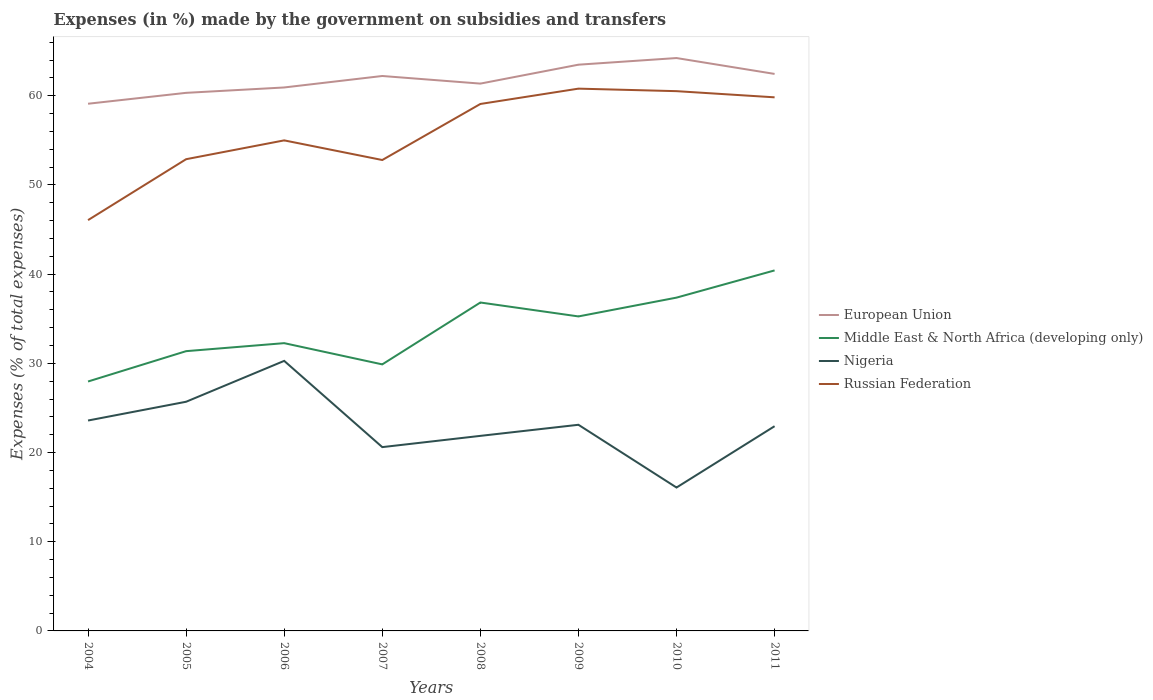Is the number of lines equal to the number of legend labels?
Provide a short and direct response. Yes. Across all years, what is the maximum percentage of expenses made by the government on subsidies and transfers in European Union?
Your answer should be very brief. 59.11. In which year was the percentage of expenses made by the government on subsidies and transfers in Nigeria maximum?
Provide a succinct answer. 2010. What is the total percentage of expenses made by the government on subsidies and transfers in European Union in the graph?
Offer a very short reply. -2.12. What is the difference between the highest and the second highest percentage of expenses made by the government on subsidies and transfers in Middle East & North Africa (developing only)?
Provide a short and direct response. 12.46. What is the difference between the highest and the lowest percentage of expenses made by the government on subsidies and transfers in Nigeria?
Ensure brevity in your answer.  4. How many lines are there?
Provide a short and direct response. 4. What is the difference between two consecutive major ticks on the Y-axis?
Offer a terse response. 10. Does the graph contain grids?
Your answer should be compact. No. Where does the legend appear in the graph?
Provide a short and direct response. Center right. How are the legend labels stacked?
Your answer should be compact. Vertical. What is the title of the graph?
Your answer should be very brief. Expenses (in %) made by the government on subsidies and transfers. What is the label or title of the Y-axis?
Offer a very short reply. Expenses (% of total expenses). What is the Expenses (% of total expenses) of European Union in 2004?
Your answer should be very brief. 59.11. What is the Expenses (% of total expenses) of Middle East & North Africa (developing only) in 2004?
Offer a terse response. 27.96. What is the Expenses (% of total expenses) of Nigeria in 2004?
Your answer should be compact. 23.59. What is the Expenses (% of total expenses) of Russian Federation in 2004?
Make the answer very short. 46.06. What is the Expenses (% of total expenses) of European Union in 2005?
Give a very brief answer. 60.33. What is the Expenses (% of total expenses) in Middle East & North Africa (developing only) in 2005?
Your response must be concise. 31.37. What is the Expenses (% of total expenses) in Nigeria in 2005?
Your response must be concise. 25.69. What is the Expenses (% of total expenses) in Russian Federation in 2005?
Your answer should be very brief. 52.89. What is the Expenses (% of total expenses) of European Union in 2006?
Provide a short and direct response. 60.93. What is the Expenses (% of total expenses) in Middle East & North Africa (developing only) in 2006?
Your answer should be very brief. 32.26. What is the Expenses (% of total expenses) of Nigeria in 2006?
Offer a very short reply. 30.28. What is the Expenses (% of total expenses) in Russian Federation in 2006?
Your response must be concise. 55. What is the Expenses (% of total expenses) of European Union in 2007?
Your answer should be compact. 62.22. What is the Expenses (% of total expenses) in Middle East & North Africa (developing only) in 2007?
Your answer should be compact. 29.88. What is the Expenses (% of total expenses) of Nigeria in 2007?
Provide a succinct answer. 20.61. What is the Expenses (% of total expenses) of Russian Federation in 2007?
Your response must be concise. 52.8. What is the Expenses (% of total expenses) in European Union in 2008?
Provide a short and direct response. 61.36. What is the Expenses (% of total expenses) in Middle East & North Africa (developing only) in 2008?
Offer a very short reply. 36.82. What is the Expenses (% of total expenses) of Nigeria in 2008?
Ensure brevity in your answer.  21.87. What is the Expenses (% of total expenses) in Russian Federation in 2008?
Your response must be concise. 59.08. What is the Expenses (% of total expenses) of European Union in 2009?
Your answer should be compact. 63.49. What is the Expenses (% of total expenses) in Middle East & North Africa (developing only) in 2009?
Keep it short and to the point. 35.26. What is the Expenses (% of total expenses) in Nigeria in 2009?
Provide a short and direct response. 23.11. What is the Expenses (% of total expenses) of Russian Federation in 2009?
Your answer should be compact. 60.8. What is the Expenses (% of total expenses) of European Union in 2010?
Your answer should be very brief. 64.23. What is the Expenses (% of total expenses) in Middle East & North Africa (developing only) in 2010?
Ensure brevity in your answer.  37.37. What is the Expenses (% of total expenses) of Nigeria in 2010?
Make the answer very short. 16.08. What is the Expenses (% of total expenses) of Russian Federation in 2010?
Provide a succinct answer. 60.52. What is the Expenses (% of total expenses) of European Union in 2011?
Make the answer very short. 62.45. What is the Expenses (% of total expenses) of Middle East & North Africa (developing only) in 2011?
Provide a short and direct response. 40.42. What is the Expenses (% of total expenses) in Nigeria in 2011?
Your answer should be very brief. 22.95. What is the Expenses (% of total expenses) of Russian Federation in 2011?
Offer a very short reply. 59.83. Across all years, what is the maximum Expenses (% of total expenses) in European Union?
Keep it short and to the point. 64.23. Across all years, what is the maximum Expenses (% of total expenses) of Middle East & North Africa (developing only)?
Keep it short and to the point. 40.42. Across all years, what is the maximum Expenses (% of total expenses) in Nigeria?
Keep it short and to the point. 30.28. Across all years, what is the maximum Expenses (% of total expenses) in Russian Federation?
Provide a succinct answer. 60.8. Across all years, what is the minimum Expenses (% of total expenses) of European Union?
Ensure brevity in your answer.  59.11. Across all years, what is the minimum Expenses (% of total expenses) of Middle East & North Africa (developing only)?
Your answer should be compact. 27.96. Across all years, what is the minimum Expenses (% of total expenses) of Nigeria?
Give a very brief answer. 16.08. Across all years, what is the minimum Expenses (% of total expenses) of Russian Federation?
Your answer should be very brief. 46.06. What is the total Expenses (% of total expenses) of European Union in the graph?
Offer a terse response. 494.11. What is the total Expenses (% of total expenses) of Middle East & North Africa (developing only) in the graph?
Your answer should be very brief. 271.35. What is the total Expenses (% of total expenses) in Nigeria in the graph?
Provide a succinct answer. 184.18. What is the total Expenses (% of total expenses) of Russian Federation in the graph?
Provide a succinct answer. 446.97. What is the difference between the Expenses (% of total expenses) in European Union in 2004 and that in 2005?
Offer a very short reply. -1.22. What is the difference between the Expenses (% of total expenses) in Middle East & North Africa (developing only) in 2004 and that in 2005?
Make the answer very short. -3.4. What is the difference between the Expenses (% of total expenses) in Nigeria in 2004 and that in 2005?
Your answer should be very brief. -2.1. What is the difference between the Expenses (% of total expenses) of Russian Federation in 2004 and that in 2005?
Give a very brief answer. -6.83. What is the difference between the Expenses (% of total expenses) of European Union in 2004 and that in 2006?
Offer a very short reply. -1.83. What is the difference between the Expenses (% of total expenses) in Middle East & North Africa (developing only) in 2004 and that in 2006?
Offer a very short reply. -4.3. What is the difference between the Expenses (% of total expenses) of Nigeria in 2004 and that in 2006?
Provide a succinct answer. -6.69. What is the difference between the Expenses (% of total expenses) of Russian Federation in 2004 and that in 2006?
Give a very brief answer. -8.94. What is the difference between the Expenses (% of total expenses) in European Union in 2004 and that in 2007?
Offer a terse response. -3.11. What is the difference between the Expenses (% of total expenses) of Middle East & North Africa (developing only) in 2004 and that in 2007?
Offer a very short reply. -1.92. What is the difference between the Expenses (% of total expenses) of Nigeria in 2004 and that in 2007?
Your response must be concise. 2.98. What is the difference between the Expenses (% of total expenses) in Russian Federation in 2004 and that in 2007?
Provide a short and direct response. -6.74. What is the difference between the Expenses (% of total expenses) of European Union in 2004 and that in 2008?
Offer a very short reply. -2.26. What is the difference between the Expenses (% of total expenses) in Middle East & North Africa (developing only) in 2004 and that in 2008?
Give a very brief answer. -8.86. What is the difference between the Expenses (% of total expenses) of Nigeria in 2004 and that in 2008?
Provide a short and direct response. 1.72. What is the difference between the Expenses (% of total expenses) in Russian Federation in 2004 and that in 2008?
Make the answer very short. -13.02. What is the difference between the Expenses (% of total expenses) of European Union in 2004 and that in 2009?
Offer a terse response. -4.38. What is the difference between the Expenses (% of total expenses) of Middle East & North Africa (developing only) in 2004 and that in 2009?
Ensure brevity in your answer.  -7.3. What is the difference between the Expenses (% of total expenses) in Nigeria in 2004 and that in 2009?
Offer a very short reply. 0.48. What is the difference between the Expenses (% of total expenses) in Russian Federation in 2004 and that in 2009?
Your response must be concise. -14.74. What is the difference between the Expenses (% of total expenses) in European Union in 2004 and that in 2010?
Ensure brevity in your answer.  -5.12. What is the difference between the Expenses (% of total expenses) of Middle East & North Africa (developing only) in 2004 and that in 2010?
Offer a terse response. -9.4. What is the difference between the Expenses (% of total expenses) of Nigeria in 2004 and that in 2010?
Offer a terse response. 7.51. What is the difference between the Expenses (% of total expenses) of Russian Federation in 2004 and that in 2010?
Offer a terse response. -14.46. What is the difference between the Expenses (% of total expenses) of European Union in 2004 and that in 2011?
Your answer should be very brief. -3.34. What is the difference between the Expenses (% of total expenses) in Middle East & North Africa (developing only) in 2004 and that in 2011?
Give a very brief answer. -12.46. What is the difference between the Expenses (% of total expenses) in Nigeria in 2004 and that in 2011?
Provide a succinct answer. 0.64. What is the difference between the Expenses (% of total expenses) in Russian Federation in 2004 and that in 2011?
Ensure brevity in your answer.  -13.77. What is the difference between the Expenses (% of total expenses) of European Union in 2005 and that in 2006?
Give a very brief answer. -0.6. What is the difference between the Expenses (% of total expenses) of Middle East & North Africa (developing only) in 2005 and that in 2006?
Provide a short and direct response. -0.9. What is the difference between the Expenses (% of total expenses) of Nigeria in 2005 and that in 2006?
Provide a short and direct response. -4.58. What is the difference between the Expenses (% of total expenses) in Russian Federation in 2005 and that in 2006?
Keep it short and to the point. -2.11. What is the difference between the Expenses (% of total expenses) of European Union in 2005 and that in 2007?
Your answer should be compact. -1.89. What is the difference between the Expenses (% of total expenses) in Middle East & North Africa (developing only) in 2005 and that in 2007?
Your answer should be compact. 1.48. What is the difference between the Expenses (% of total expenses) in Nigeria in 2005 and that in 2007?
Give a very brief answer. 5.09. What is the difference between the Expenses (% of total expenses) of Russian Federation in 2005 and that in 2007?
Provide a short and direct response. 0.09. What is the difference between the Expenses (% of total expenses) in European Union in 2005 and that in 2008?
Offer a very short reply. -1.04. What is the difference between the Expenses (% of total expenses) in Middle East & North Africa (developing only) in 2005 and that in 2008?
Give a very brief answer. -5.45. What is the difference between the Expenses (% of total expenses) in Nigeria in 2005 and that in 2008?
Give a very brief answer. 3.83. What is the difference between the Expenses (% of total expenses) in Russian Federation in 2005 and that in 2008?
Give a very brief answer. -6.19. What is the difference between the Expenses (% of total expenses) in European Union in 2005 and that in 2009?
Provide a short and direct response. -3.16. What is the difference between the Expenses (% of total expenses) of Middle East & North Africa (developing only) in 2005 and that in 2009?
Give a very brief answer. -3.89. What is the difference between the Expenses (% of total expenses) of Nigeria in 2005 and that in 2009?
Ensure brevity in your answer.  2.58. What is the difference between the Expenses (% of total expenses) of Russian Federation in 2005 and that in 2009?
Your answer should be very brief. -7.91. What is the difference between the Expenses (% of total expenses) in European Union in 2005 and that in 2010?
Provide a short and direct response. -3.9. What is the difference between the Expenses (% of total expenses) in Middle East & North Africa (developing only) in 2005 and that in 2010?
Provide a short and direct response. -6. What is the difference between the Expenses (% of total expenses) of Nigeria in 2005 and that in 2010?
Offer a terse response. 9.62. What is the difference between the Expenses (% of total expenses) of Russian Federation in 2005 and that in 2010?
Your answer should be compact. -7.63. What is the difference between the Expenses (% of total expenses) of European Union in 2005 and that in 2011?
Provide a short and direct response. -2.12. What is the difference between the Expenses (% of total expenses) of Middle East & North Africa (developing only) in 2005 and that in 2011?
Make the answer very short. -9.05. What is the difference between the Expenses (% of total expenses) of Nigeria in 2005 and that in 2011?
Give a very brief answer. 2.74. What is the difference between the Expenses (% of total expenses) of Russian Federation in 2005 and that in 2011?
Give a very brief answer. -6.94. What is the difference between the Expenses (% of total expenses) of European Union in 2006 and that in 2007?
Your response must be concise. -1.29. What is the difference between the Expenses (% of total expenses) of Middle East & North Africa (developing only) in 2006 and that in 2007?
Provide a succinct answer. 2.38. What is the difference between the Expenses (% of total expenses) of Nigeria in 2006 and that in 2007?
Your answer should be very brief. 9.67. What is the difference between the Expenses (% of total expenses) of Russian Federation in 2006 and that in 2007?
Offer a terse response. 2.2. What is the difference between the Expenses (% of total expenses) in European Union in 2006 and that in 2008?
Your answer should be compact. -0.43. What is the difference between the Expenses (% of total expenses) in Middle East & North Africa (developing only) in 2006 and that in 2008?
Give a very brief answer. -4.56. What is the difference between the Expenses (% of total expenses) in Nigeria in 2006 and that in 2008?
Offer a very short reply. 8.41. What is the difference between the Expenses (% of total expenses) in Russian Federation in 2006 and that in 2008?
Give a very brief answer. -4.08. What is the difference between the Expenses (% of total expenses) in European Union in 2006 and that in 2009?
Ensure brevity in your answer.  -2.55. What is the difference between the Expenses (% of total expenses) of Middle East & North Africa (developing only) in 2006 and that in 2009?
Make the answer very short. -3. What is the difference between the Expenses (% of total expenses) of Nigeria in 2006 and that in 2009?
Provide a succinct answer. 7.17. What is the difference between the Expenses (% of total expenses) in Russian Federation in 2006 and that in 2009?
Provide a succinct answer. -5.8. What is the difference between the Expenses (% of total expenses) in European Union in 2006 and that in 2010?
Your answer should be compact. -3.3. What is the difference between the Expenses (% of total expenses) in Middle East & North Africa (developing only) in 2006 and that in 2010?
Keep it short and to the point. -5.1. What is the difference between the Expenses (% of total expenses) of Nigeria in 2006 and that in 2010?
Your answer should be very brief. 14.2. What is the difference between the Expenses (% of total expenses) in Russian Federation in 2006 and that in 2010?
Your answer should be very brief. -5.52. What is the difference between the Expenses (% of total expenses) in European Union in 2006 and that in 2011?
Keep it short and to the point. -1.52. What is the difference between the Expenses (% of total expenses) in Middle East & North Africa (developing only) in 2006 and that in 2011?
Your response must be concise. -8.16. What is the difference between the Expenses (% of total expenses) of Nigeria in 2006 and that in 2011?
Ensure brevity in your answer.  7.32. What is the difference between the Expenses (% of total expenses) of Russian Federation in 2006 and that in 2011?
Give a very brief answer. -4.83. What is the difference between the Expenses (% of total expenses) of European Union in 2007 and that in 2008?
Keep it short and to the point. 0.85. What is the difference between the Expenses (% of total expenses) in Middle East & North Africa (developing only) in 2007 and that in 2008?
Offer a terse response. -6.94. What is the difference between the Expenses (% of total expenses) of Nigeria in 2007 and that in 2008?
Keep it short and to the point. -1.26. What is the difference between the Expenses (% of total expenses) of Russian Federation in 2007 and that in 2008?
Provide a short and direct response. -6.28. What is the difference between the Expenses (% of total expenses) in European Union in 2007 and that in 2009?
Ensure brevity in your answer.  -1.27. What is the difference between the Expenses (% of total expenses) of Middle East & North Africa (developing only) in 2007 and that in 2009?
Make the answer very short. -5.38. What is the difference between the Expenses (% of total expenses) of Nigeria in 2007 and that in 2009?
Offer a very short reply. -2.5. What is the difference between the Expenses (% of total expenses) in Russian Federation in 2007 and that in 2009?
Your answer should be very brief. -8. What is the difference between the Expenses (% of total expenses) of European Union in 2007 and that in 2010?
Keep it short and to the point. -2.01. What is the difference between the Expenses (% of total expenses) of Middle East & North Africa (developing only) in 2007 and that in 2010?
Provide a succinct answer. -7.48. What is the difference between the Expenses (% of total expenses) in Nigeria in 2007 and that in 2010?
Give a very brief answer. 4.53. What is the difference between the Expenses (% of total expenses) of Russian Federation in 2007 and that in 2010?
Give a very brief answer. -7.72. What is the difference between the Expenses (% of total expenses) in European Union in 2007 and that in 2011?
Make the answer very short. -0.23. What is the difference between the Expenses (% of total expenses) in Middle East & North Africa (developing only) in 2007 and that in 2011?
Provide a succinct answer. -10.54. What is the difference between the Expenses (% of total expenses) in Nigeria in 2007 and that in 2011?
Offer a very short reply. -2.35. What is the difference between the Expenses (% of total expenses) of Russian Federation in 2007 and that in 2011?
Keep it short and to the point. -7.03. What is the difference between the Expenses (% of total expenses) in European Union in 2008 and that in 2009?
Your answer should be compact. -2.12. What is the difference between the Expenses (% of total expenses) of Middle East & North Africa (developing only) in 2008 and that in 2009?
Make the answer very short. 1.56. What is the difference between the Expenses (% of total expenses) of Nigeria in 2008 and that in 2009?
Provide a succinct answer. -1.24. What is the difference between the Expenses (% of total expenses) in Russian Federation in 2008 and that in 2009?
Provide a succinct answer. -1.72. What is the difference between the Expenses (% of total expenses) in European Union in 2008 and that in 2010?
Keep it short and to the point. -2.87. What is the difference between the Expenses (% of total expenses) of Middle East & North Africa (developing only) in 2008 and that in 2010?
Make the answer very short. -0.55. What is the difference between the Expenses (% of total expenses) in Nigeria in 2008 and that in 2010?
Provide a succinct answer. 5.79. What is the difference between the Expenses (% of total expenses) of Russian Federation in 2008 and that in 2010?
Make the answer very short. -1.44. What is the difference between the Expenses (% of total expenses) in European Union in 2008 and that in 2011?
Your response must be concise. -1.09. What is the difference between the Expenses (% of total expenses) of Middle East & North Africa (developing only) in 2008 and that in 2011?
Your answer should be compact. -3.6. What is the difference between the Expenses (% of total expenses) in Nigeria in 2008 and that in 2011?
Offer a terse response. -1.09. What is the difference between the Expenses (% of total expenses) of Russian Federation in 2008 and that in 2011?
Your answer should be compact. -0.74. What is the difference between the Expenses (% of total expenses) in European Union in 2009 and that in 2010?
Provide a short and direct response. -0.74. What is the difference between the Expenses (% of total expenses) of Middle East & North Africa (developing only) in 2009 and that in 2010?
Keep it short and to the point. -2.11. What is the difference between the Expenses (% of total expenses) of Nigeria in 2009 and that in 2010?
Give a very brief answer. 7.03. What is the difference between the Expenses (% of total expenses) in Russian Federation in 2009 and that in 2010?
Your response must be concise. 0.28. What is the difference between the Expenses (% of total expenses) in European Union in 2009 and that in 2011?
Ensure brevity in your answer.  1.04. What is the difference between the Expenses (% of total expenses) of Middle East & North Africa (developing only) in 2009 and that in 2011?
Offer a very short reply. -5.16. What is the difference between the Expenses (% of total expenses) in Nigeria in 2009 and that in 2011?
Offer a terse response. 0.16. What is the difference between the Expenses (% of total expenses) of Russian Federation in 2009 and that in 2011?
Make the answer very short. 0.97. What is the difference between the Expenses (% of total expenses) of European Union in 2010 and that in 2011?
Offer a very short reply. 1.78. What is the difference between the Expenses (% of total expenses) in Middle East & North Africa (developing only) in 2010 and that in 2011?
Give a very brief answer. -3.05. What is the difference between the Expenses (% of total expenses) in Nigeria in 2010 and that in 2011?
Ensure brevity in your answer.  -6.88. What is the difference between the Expenses (% of total expenses) in Russian Federation in 2010 and that in 2011?
Offer a very short reply. 0.69. What is the difference between the Expenses (% of total expenses) of European Union in 2004 and the Expenses (% of total expenses) of Middle East & North Africa (developing only) in 2005?
Provide a succinct answer. 27.74. What is the difference between the Expenses (% of total expenses) of European Union in 2004 and the Expenses (% of total expenses) of Nigeria in 2005?
Ensure brevity in your answer.  33.41. What is the difference between the Expenses (% of total expenses) in European Union in 2004 and the Expenses (% of total expenses) in Russian Federation in 2005?
Make the answer very short. 6.22. What is the difference between the Expenses (% of total expenses) of Middle East & North Africa (developing only) in 2004 and the Expenses (% of total expenses) of Nigeria in 2005?
Provide a short and direct response. 2.27. What is the difference between the Expenses (% of total expenses) of Middle East & North Africa (developing only) in 2004 and the Expenses (% of total expenses) of Russian Federation in 2005?
Your answer should be compact. -24.93. What is the difference between the Expenses (% of total expenses) in Nigeria in 2004 and the Expenses (% of total expenses) in Russian Federation in 2005?
Offer a terse response. -29.3. What is the difference between the Expenses (% of total expenses) in European Union in 2004 and the Expenses (% of total expenses) in Middle East & North Africa (developing only) in 2006?
Offer a terse response. 26.84. What is the difference between the Expenses (% of total expenses) in European Union in 2004 and the Expenses (% of total expenses) in Nigeria in 2006?
Offer a terse response. 28.83. What is the difference between the Expenses (% of total expenses) in European Union in 2004 and the Expenses (% of total expenses) in Russian Federation in 2006?
Your answer should be very brief. 4.11. What is the difference between the Expenses (% of total expenses) in Middle East & North Africa (developing only) in 2004 and the Expenses (% of total expenses) in Nigeria in 2006?
Offer a terse response. -2.31. What is the difference between the Expenses (% of total expenses) in Middle East & North Africa (developing only) in 2004 and the Expenses (% of total expenses) in Russian Federation in 2006?
Your answer should be very brief. -27.04. What is the difference between the Expenses (% of total expenses) of Nigeria in 2004 and the Expenses (% of total expenses) of Russian Federation in 2006?
Provide a short and direct response. -31.41. What is the difference between the Expenses (% of total expenses) in European Union in 2004 and the Expenses (% of total expenses) in Middle East & North Africa (developing only) in 2007?
Offer a very short reply. 29.22. What is the difference between the Expenses (% of total expenses) in European Union in 2004 and the Expenses (% of total expenses) in Nigeria in 2007?
Provide a succinct answer. 38.5. What is the difference between the Expenses (% of total expenses) in European Union in 2004 and the Expenses (% of total expenses) in Russian Federation in 2007?
Your answer should be very brief. 6.31. What is the difference between the Expenses (% of total expenses) in Middle East & North Africa (developing only) in 2004 and the Expenses (% of total expenses) in Nigeria in 2007?
Ensure brevity in your answer.  7.36. What is the difference between the Expenses (% of total expenses) in Middle East & North Africa (developing only) in 2004 and the Expenses (% of total expenses) in Russian Federation in 2007?
Your response must be concise. -24.83. What is the difference between the Expenses (% of total expenses) in Nigeria in 2004 and the Expenses (% of total expenses) in Russian Federation in 2007?
Make the answer very short. -29.21. What is the difference between the Expenses (% of total expenses) of European Union in 2004 and the Expenses (% of total expenses) of Middle East & North Africa (developing only) in 2008?
Provide a succinct answer. 22.29. What is the difference between the Expenses (% of total expenses) of European Union in 2004 and the Expenses (% of total expenses) of Nigeria in 2008?
Make the answer very short. 37.24. What is the difference between the Expenses (% of total expenses) of European Union in 2004 and the Expenses (% of total expenses) of Russian Federation in 2008?
Offer a terse response. 0.03. What is the difference between the Expenses (% of total expenses) in Middle East & North Africa (developing only) in 2004 and the Expenses (% of total expenses) in Nigeria in 2008?
Give a very brief answer. 6.1. What is the difference between the Expenses (% of total expenses) of Middle East & North Africa (developing only) in 2004 and the Expenses (% of total expenses) of Russian Federation in 2008?
Provide a succinct answer. -31.12. What is the difference between the Expenses (% of total expenses) of Nigeria in 2004 and the Expenses (% of total expenses) of Russian Federation in 2008?
Make the answer very short. -35.49. What is the difference between the Expenses (% of total expenses) in European Union in 2004 and the Expenses (% of total expenses) in Middle East & North Africa (developing only) in 2009?
Your answer should be very brief. 23.85. What is the difference between the Expenses (% of total expenses) in European Union in 2004 and the Expenses (% of total expenses) in Nigeria in 2009?
Keep it short and to the point. 35.99. What is the difference between the Expenses (% of total expenses) in European Union in 2004 and the Expenses (% of total expenses) in Russian Federation in 2009?
Your response must be concise. -1.69. What is the difference between the Expenses (% of total expenses) of Middle East & North Africa (developing only) in 2004 and the Expenses (% of total expenses) of Nigeria in 2009?
Ensure brevity in your answer.  4.85. What is the difference between the Expenses (% of total expenses) in Middle East & North Africa (developing only) in 2004 and the Expenses (% of total expenses) in Russian Federation in 2009?
Your response must be concise. -32.84. What is the difference between the Expenses (% of total expenses) in Nigeria in 2004 and the Expenses (% of total expenses) in Russian Federation in 2009?
Ensure brevity in your answer.  -37.21. What is the difference between the Expenses (% of total expenses) of European Union in 2004 and the Expenses (% of total expenses) of Middle East & North Africa (developing only) in 2010?
Offer a very short reply. 21.74. What is the difference between the Expenses (% of total expenses) in European Union in 2004 and the Expenses (% of total expenses) in Nigeria in 2010?
Ensure brevity in your answer.  43.03. What is the difference between the Expenses (% of total expenses) of European Union in 2004 and the Expenses (% of total expenses) of Russian Federation in 2010?
Provide a short and direct response. -1.41. What is the difference between the Expenses (% of total expenses) in Middle East & North Africa (developing only) in 2004 and the Expenses (% of total expenses) in Nigeria in 2010?
Provide a short and direct response. 11.89. What is the difference between the Expenses (% of total expenses) of Middle East & North Africa (developing only) in 2004 and the Expenses (% of total expenses) of Russian Federation in 2010?
Offer a very short reply. -32.55. What is the difference between the Expenses (% of total expenses) in Nigeria in 2004 and the Expenses (% of total expenses) in Russian Federation in 2010?
Your answer should be compact. -36.93. What is the difference between the Expenses (% of total expenses) in European Union in 2004 and the Expenses (% of total expenses) in Middle East & North Africa (developing only) in 2011?
Your answer should be compact. 18.69. What is the difference between the Expenses (% of total expenses) in European Union in 2004 and the Expenses (% of total expenses) in Nigeria in 2011?
Your response must be concise. 36.15. What is the difference between the Expenses (% of total expenses) in European Union in 2004 and the Expenses (% of total expenses) in Russian Federation in 2011?
Ensure brevity in your answer.  -0.72. What is the difference between the Expenses (% of total expenses) in Middle East & North Africa (developing only) in 2004 and the Expenses (% of total expenses) in Nigeria in 2011?
Your answer should be compact. 5.01. What is the difference between the Expenses (% of total expenses) of Middle East & North Africa (developing only) in 2004 and the Expenses (% of total expenses) of Russian Federation in 2011?
Give a very brief answer. -31.86. What is the difference between the Expenses (% of total expenses) in Nigeria in 2004 and the Expenses (% of total expenses) in Russian Federation in 2011?
Your response must be concise. -36.23. What is the difference between the Expenses (% of total expenses) of European Union in 2005 and the Expenses (% of total expenses) of Middle East & North Africa (developing only) in 2006?
Offer a very short reply. 28.06. What is the difference between the Expenses (% of total expenses) in European Union in 2005 and the Expenses (% of total expenses) in Nigeria in 2006?
Your response must be concise. 30.05. What is the difference between the Expenses (% of total expenses) in European Union in 2005 and the Expenses (% of total expenses) in Russian Federation in 2006?
Offer a terse response. 5.33. What is the difference between the Expenses (% of total expenses) in Middle East & North Africa (developing only) in 2005 and the Expenses (% of total expenses) in Nigeria in 2006?
Give a very brief answer. 1.09. What is the difference between the Expenses (% of total expenses) in Middle East & North Africa (developing only) in 2005 and the Expenses (% of total expenses) in Russian Federation in 2006?
Your response must be concise. -23.63. What is the difference between the Expenses (% of total expenses) of Nigeria in 2005 and the Expenses (% of total expenses) of Russian Federation in 2006?
Your answer should be compact. -29.3. What is the difference between the Expenses (% of total expenses) of European Union in 2005 and the Expenses (% of total expenses) of Middle East & North Africa (developing only) in 2007?
Your answer should be very brief. 30.44. What is the difference between the Expenses (% of total expenses) in European Union in 2005 and the Expenses (% of total expenses) in Nigeria in 2007?
Give a very brief answer. 39.72. What is the difference between the Expenses (% of total expenses) of European Union in 2005 and the Expenses (% of total expenses) of Russian Federation in 2007?
Your response must be concise. 7.53. What is the difference between the Expenses (% of total expenses) of Middle East & North Africa (developing only) in 2005 and the Expenses (% of total expenses) of Nigeria in 2007?
Offer a very short reply. 10.76. What is the difference between the Expenses (% of total expenses) in Middle East & North Africa (developing only) in 2005 and the Expenses (% of total expenses) in Russian Federation in 2007?
Keep it short and to the point. -21.43. What is the difference between the Expenses (% of total expenses) of Nigeria in 2005 and the Expenses (% of total expenses) of Russian Federation in 2007?
Keep it short and to the point. -27.1. What is the difference between the Expenses (% of total expenses) in European Union in 2005 and the Expenses (% of total expenses) in Middle East & North Africa (developing only) in 2008?
Ensure brevity in your answer.  23.51. What is the difference between the Expenses (% of total expenses) in European Union in 2005 and the Expenses (% of total expenses) in Nigeria in 2008?
Give a very brief answer. 38.46. What is the difference between the Expenses (% of total expenses) of European Union in 2005 and the Expenses (% of total expenses) of Russian Federation in 2008?
Provide a succinct answer. 1.25. What is the difference between the Expenses (% of total expenses) of Middle East & North Africa (developing only) in 2005 and the Expenses (% of total expenses) of Nigeria in 2008?
Provide a short and direct response. 9.5. What is the difference between the Expenses (% of total expenses) of Middle East & North Africa (developing only) in 2005 and the Expenses (% of total expenses) of Russian Federation in 2008?
Make the answer very short. -27.71. What is the difference between the Expenses (% of total expenses) of Nigeria in 2005 and the Expenses (% of total expenses) of Russian Federation in 2008?
Your answer should be very brief. -33.39. What is the difference between the Expenses (% of total expenses) of European Union in 2005 and the Expenses (% of total expenses) of Middle East & North Africa (developing only) in 2009?
Provide a short and direct response. 25.07. What is the difference between the Expenses (% of total expenses) in European Union in 2005 and the Expenses (% of total expenses) in Nigeria in 2009?
Provide a succinct answer. 37.22. What is the difference between the Expenses (% of total expenses) in European Union in 2005 and the Expenses (% of total expenses) in Russian Federation in 2009?
Provide a short and direct response. -0.47. What is the difference between the Expenses (% of total expenses) in Middle East & North Africa (developing only) in 2005 and the Expenses (% of total expenses) in Nigeria in 2009?
Keep it short and to the point. 8.26. What is the difference between the Expenses (% of total expenses) of Middle East & North Africa (developing only) in 2005 and the Expenses (% of total expenses) of Russian Federation in 2009?
Your response must be concise. -29.43. What is the difference between the Expenses (% of total expenses) of Nigeria in 2005 and the Expenses (% of total expenses) of Russian Federation in 2009?
Offer a very short reply. -35.1. What is the difference between the Expenses (% of total expenses) in European Union in 2005 and the Expenses (% of total expenses) in Middle East & North Africa (developing only) in 2010?
Ensure brevity in your answer.  22.96. What is the difference between the Expenses (% of total expenses) in European Union in 2005 and the Expenses (% of total expenses) in Nigeria in 2010?
Ensure brevity in your answer.  44.25. What is the difference between the Expenses (% of total expenses) of European Union in 2005 and the Expenses (% of total expenses) of Russian Federation in 2010?
Offer a terse response. -0.19. What is the difference between the Expenses (% of total expenses) in Middle East & North Africa (developing only) in 2005 and the Expenses (% of total expenses) in Nigeria in 2010?
Provide a short and direct response. 15.29. What is the difference between the Expenses (% of total expenses) of Middle East & North Africa (developing only) in 2005 and the Expenses (% of total expenses) of Russian Federation in 2010?
Offer a very short reply. -29.15. What is the difference between the Expenses (% of total expenses) in Nigeria in 2005 and the Expenses (% of total expenses) in Russian Federation in 2010?
Offer a terse response. -34.82. What is the difference between the Expenses (% of total expenses) in European Union in 2005 and the Expenses (% of total expenses) in Middle East & North Africa (developing only) in 2011?
Offer a terse response. 19.91. What is the difference between the Expenses (% of total expenses) in European Union in 2005 and the Expenses (% of total expenses) in Nigeria in 2011?
Keep it short and to the point. 37.37. What is the difference between the Expenses (% of total expenses) of European Union in 2005 and the Expenses (% of total expenses) of Russian Federation in 2011?
Give a very brief answer. 0.5. What is the difference between the Expenses (% of total expenses) of Middle East & North Africa (developing only) in 2005 and the Expenses (% of total expenses) of Nigeria in 2011?
Your answer should be compact. 8.41. What is the difference between the Expenses (% of total expenses) of Middle East & North Africa (developing only) in 2005 and the Expenses (% of total expenses) of Russian Federation in 2011?
Your answer should be very brief. -28.46. What is the difference between the Expenses (% of total expenses) in Nigeria in 2005 and the Expenses (% of total expenses) in Russian Federation in 2011?
Offer a terse response. -34.13. What is the difference between the Expenses (% of total expenses) in European Union in 2006 and the Expenses (% of total expenses) in Middle East & North Africa (developing only) in 2007?
Offer a terse response. 31.05. What is the difference between the Expenses (% of total expenses) of European Union in 2006 and the Expenses (% of total expenses) of Nigeria in 2007?
Your answer should be compact. 40.32. What is the difference between the Expenses (% of total expenses) of European Union in 2006 and the Expenses (% of total expenses) of Russian Federation in 2007?
Your answer should be very brief. 8.13. What is the difference between the Expenses (% of total expenses) of Middle East & North Africa (developing only) in 2006 and the Expenses (% of total expenses) of Nigeria in 2007?
Offer a very short reply. 11.66. What is the difference between the Expenses (% of total expenses) in Middle East & North Africa (developing only) in 2006 and the Expenses (% of total expenses) in Russian Federation in 2007?
Give a very brief answer. -20.53. What is the difference between the Expenses (% of total expenses) of Nigeria in 2006 and the Expenses (% of total expenses) of Russian Federation in 2007?
Keep it short and to the point. -22.52. What is the difference between the Expenses (% of total expenses) of European Union in 2006 and the Expenses (% of total expenses) of Middle East & North Africa (developing only) in 2008?
Make the answer very short. 24.11. What is the difference between the Expenses (% of total expenses) in European Union in 2006 and the Expenses (% of total expenses) in Nigeria in 2008?
Ensure brevity in your answer.  39.06. What is the difference between the Expenses (% of total expenses) in European Union in 2006 and the Expenses (% of total expenses) in Russian Federation in 2008?
Offer a very short reply. 1.85. What is the difference between the Expenses (% of total expenses) in Middle East & North Africa (developing only) in 2006 and the Expenses (% of total expenses) in Nigeria in 2008?
Give a very brief answer. 10.4. What is the difference between the Expenses (% of total expenses) of Middle East & North Africa (developing only) in 2006 and the Expenses (% of total expenses) of Russian Federation in 2008?
Provide a short and direct response. -26.82. What is the difference between the Expenses (% of total expenses) in Nigeria in 2006 and the Expenses (% of total expenses) in Russian Federation in 2008?
Your answer should be very brief. -28.8. What is the difference between the Expenses (% of total expenses) of European Union in 2006 and the Expenses (% of total expenses) of Middle East & North Africa (developing only) in 2009?
Provide a succinct answer. 25.67. What is the difference between the Expenses (% of total expenses) in European Union in 2006 and the Expenses (% of total expenses) in Nigeria in 2009?
Provide a succinct answer. 37.82. What is the difference between the Expenses (% of total expenses) of European Union in 2006 and the Expenses (% of total expenses) of Russian Federation in 2009?
Provide a succinct answer. 0.13. What is the difference between the Expenses (% of total expenses) in Middle East & North Africa (developing only) in 2006 and the Expenses (% of total expenses) in Nigeria in 2009?
Offer a very short reply. 9.15. What is the difference between the Expenses (% of total expenses) in Middle East & North Africa (developing only) in 2006 and the Expenses (% of total expenses) in Russian Federation in 2009?
Make the answer very short. -28.53. What is the difference between the Expenses (% of total expenses) in Nigeria in 2006 and the Expenses (% of total expenses) in Russian Federation in 2009?
Offer a terse response. -30.52. What is the difference between the Expenses (% of total expenses) in European Union in 2006 and the Expenses (% of total expenses) in Middle East & North Africa (developing only) in 2010?
Your answer should be very brief. 23.56. What is the difference between the Expenses (% of total expenses) in European Union in 2006 and the Expenses (% of total expenses) in Nigeria in 2010?
Offer a terse response. 44.85. What is the difference between the Expenses (% of total expenses) in European Union in 2006 and the Expenses (% of total expenses) in Russian Federation in 2010?
Your answer should be compact. 0.41. What is the difference between the Expenses (% of total expenses) in Middle East & North Africa (developing only) in 2006 and the Expenses (% of total expenses) in Nigeria in 2010?
Make the answer very short. 16.19. What is the difference between the Expenses (% of total expenses) in Middle East & North Africa (developing only) in 2006 and the Expenses (% of total expenses) in Russian Federation in 2010?
Your answer should be very brief. -28.25. What is the difference between the Expenses (% of total expenses) in Nigeria in 2006 and the Expenses (% of total expenses) in Russian Federation in 2010?
Give a very brief answer. -30.24. What is the difference between the Expenses (% of total expenses) in European Union in 2006 and the Expenses (% of total expenses) in Middle East & North Africa (developing only) in 2011?
Your answer should be compact. 20.51. What is the difference between the Expenses (% of total expenses) in European Union in 2006 and the Expenses (% of total expenses) in Nigeria in 2011?
Provide a short and direct response. 37.98. What is the difference between the Expenses (% of total expenses) in European Union in 2006 and the Expenses (% of total expenses) in Russian Federation in 2011?
Your answer should be very brief. 1.11. What is the difference between the Expenses (% of total expenses) of Middle East & North Africa (developing only) in 2006 and the Expenses (% of total expenses) of Nigeria in 2011?
Provide a succinct answer. 9.31. What is the difference between the Expenses (% of total expenses) in Middle East & North Africa (developing only) in 2006 and the Expenses (% of total expenses) in Russian Federation in 2011?
Provide a succinct answer. -27.56. What is the difference between the Expenses (% of total expenses) in Nigeria in 2006 and the Expenses (% of total expenses) in Russian Federation in 2011?
Offer a very short reply. -29.55. What is the difference between the Expenses (% of total expenses) of European Union in 2007 and the Expenses (% of total expenses) of Middle East & North Africa (developing only) in 2008?
Offer a very short reply. 25.4. What is the difference between the Expenses (% of total expenses) in European Union in 2007 and the Expenses (% of total expenses) in Nigeria in 2008?
Offer a terse response. 40.35. What is the difference between the Expenses (% of total expenses) of European Union in 2007 and the Expenses (% of total expenses) of Russian Federation in 2008?
Make the answer very short. 3.14. What is the difference between the Expenses (% of total expenses) of Middle East & North Africa (developing only) in 2007 and the Expenses (% of total expenses) of Nigeria in 2008?
Your answer should be very brief. 8.02. What is the difference between the Expenses (% of total expenses) of Middle East & North Africa (developing only) in 2007 and the Expenses (% of total expenses) of Russian Federation in 2008?
Make the answer very short. -29.2. What is the difference between the Expenses (% of total expenses) of Nigeria in 2007 and the Expenses (% of total expenses) of Russian Federation in 2008?
Provide a short and direct response. -38.47. What is the difference between the Expenses (% of total expenses) in European Union in 2007 and the Expenses (% of total expenses) in Middle East & North Africa (developing only) in 2009?
Provide a succinct answer. 26.96. What is the difference between the Expenses (% of total expenses) in European Union in 2007 and the Expenses (% of total expenses) in Nigeria in 2009?
Your answer should be very brief. 39.11. What is the difference between the Expenses (% of total expenses) in European Union in 2007 and the Expenses (% of total expenses) in Russian Federation in 2009?
Your answer should be compact. 1.42. What is the difference between the Expenses (% of total expenses) in Middle East & North Africa (developing only) in 2007 and the Expenses (% of total expenses) in Nigeria in 2009?
Offer a very short reply. 6.77. What is the difference between the Expenses (% of total expenses) of Middle East & North Africa (developing only) in 2007 and the Expenses (% of total expenses) of Russian Federation in 2009?
Your answer should be compact. -30.91. What is the difference between the Expenses (% of total expenses) in Nigeria in 2007 and the Expenses (% of total expenses) in Russian Federation in 2009?
Give a very brief answer. -40.19. What is the difference between the Expenses (% of total expenses) of European Union in 2007 and the Expenses (% of total expenses) of Middle East & North Africa (developing only) in 2010?
Offer a very short reply. 24.85. What is the difference between the Expenses (% of total expenses) in European Union in 2007 and the Expenses (% of total expenses) in Nigeria in 2010?
Offer a terse response. 46.14. What is the difference between the Expenses (% of total expenses) of European Union in 2007 and the Expenses (% of total expenses) of Russian Federation in 2010?
Provide a short and direct response. 1.7. What is the difference between the Expenses (% of total expenses) of Middle East & North Africa (developing only) in 2007 and the Expenses (% of total expenses) of Nigeria in 2010?
Your answer should be very brief. 13.81. What is the difference between the Expenses (% of total expenses) of Middle East & North Africa (developing only) in 2007 and the Expenses (% of total expenses) of Russian Federation in 2010?
Offer a terse response. -30.63. What is the difference between the Expenses (% of total expenses) in Nigeria in 2007 and the Expenses (% of total expenses) in Russian Federation in 2010?
Provide a succinct answer. -39.91. What is the difference between the Expenses (% of total expenses) of European Union in 2007 and the Expenses (% of total expenses) of Middle East & North Africa (developing only) in 2011?
Provide a succinct answer. 21.8. What is the difference between the Expenses (% of total expenses) of European Union in 2007 and the Expenses (% of total expenses) of Nigeria in 2011?
Give a very brief answer. 39.26. What is the difference between the Expenses (% of total expenses) in European Union in 2007 and the Expenses (% of total expenses) in Russian Federation in 2011?
Offer a very short reply. 2.39. What is the difference between the Expenses (% of total expenses) of Middle East & North Africa (developing only) in 2007 and the Expenses (% of total expenses) of Nigeria in 2011?
Make the answer very short. 6.93. What is the difference between the Expenses (% of total expenses) of Middle East & North Africa (developing only) in 2007 and the Expenses (% of total expenses) of Russian Federation in 2011?
Your response must be concise. -29.94. What is the difference between the Expenses (% of total expenses) of Nigeria in 2007 and the Expenses (% of total expenses) of Russian Federation in 2011?
Ensure brevity in your answer.  -39.22. What is the difference between the Expenses (% of total expenses) in European Union in 2008 and the Expenses (% of total expenses) in Middle East & North Africa (developing only) in 2009?
Provide a short and direct response. 26.1. What is the difference between the Expenses (% of total expenses) of European Union in 2008 and the Expenses (% of total expenses) of Nigeria in 2009?
Your answer should be very brief. 38.25. What is the difference between the Expenses (% of total expenses) in European Union in 2008 and the Expenses (% of total expenses) in Russian Federation in 2009?
Offer a very short reply. 0.56. What is the difference between the Expenses (% of total expenses) in Middle East & North Africa (developing only) in 2008 and the Expenses (% of total expenses) in Nigeria in 2009?
Provide a succinct answer. 13.71. What is the difference between the Expenses (% of total expenses) of Middle East & North Africa (developing only) in 2008 and the Expenses (% of total expenses) of Russian Federation in 2009?
Offer a very short reply. -23.98. What is the difference between the Expenses (% of total expenses) of Nigeria in 2008 and the Expenses (% of total expenses) of Russian Federation in 2009?
Your response must be concise. -38.93. What is the difference between the Expenses (% of total expenses) of European Union in 2008 and the Expenses (% of total expenses) of Middle East & North Africa (developing only) in 2010?
Your response must be concise. 24. What is the difference between the Expenses (% of total expenses) in European Union in 2008 and the Expenses (% of total expenses) in Nigeria in 2010?
Provide a short and direct response. 45.29. What is the difference between the Expenses (% of total expenses) in European Union in 2008 and the Expenses (% of total expenses) in Russian Federation in 2010?
Your response must be concise. 0.85. What is the difference between the Expenses (% of total expenses) of Middle East & North Africa (developing only) in 2008 and the Expenses (% of total expenses) of Nigeria in 2010?
Offer a terse response. 20.74. What is the difference between the Expenses (% of total expenses) in Middle East & North Africa (developing only) in 2008 and the Expenses (% of total expenses) in Russian Federation in 2010?
Ensure brevity in your answer.  -23.7. What is the difference between the Expenses (% of total expenses) in Nigeria in 2008 and the Expenses (% of total expenses) in Russian Federation in 2010?
Make the answer very short. -38.65. What is the difference between the Expenses (% of total expenses) in European Union in 2008 and the Expenses (% of total expenses) in Middle East & North Africa (developing only) in 2011?
Make the answer very short. 20.94. What is the difference between the Expenses (% of total expenses) of European Union in 2008 and the Expenses (% of total expenses) of Nigeria in 2011?
Give a very brief answer. 38.41. What is the difference between the Expenses (% of total expenses) in European Union in 2008 and the Expenses (% of total expenses) in Russian Federation in 2011?
Your response must be concise. 1.54. What is the difference between the Expenses (% of total expenses) of Middle East & North Africa (developing only) in 2008 and the Expenses (% of total expenses) of Nigeria in 2011?
Provide a succinct answer. 13.87. What is the difference between the Expenses (% of total expenses) in Middle East & North Africa (developing only) in 2008 and the Expenses (% of total expenses) in Russian Federation in 2011?
Provide a succinct answer. -23. What is the difference between the Expenses (% of total expenses) in Nigeria in 2008 and the Expenses (% of total expenses) in Russian Federation in 2011?
Your answer should be very brief. -37.96. What is the difference between the Expenses (% of total expenses) in European Union in 2009 and the Expenses (% of total expenses) in Middle East & North Africa (developing only) in 2010?
Keep it short and to the point. 26.12. What is the difference between the Expenses (% of total expenses) of European Union in 2009 and the Expenses (% of total expenses) of Nigeria in 2010?
Ensure brevity in your answer.  47.41. What is the difference between the Expenses (% of total expenses) of European Union in 2009 and the Expenses (% of total expenses) of Russian Federation in 2010?
Your answer should be very brief. 2.97. What is the difference between the Expenses (% of total expenses) of Middle East & North Africa (developing only) in 2009 and the Expenses (% of total expenses) of Nigeria in 2010?
Make the answer very short. 19.18. What is the difference between the Expenses (% of total expenses) in Middle East & North Africa (developing only) in 2009 and the Expenses (% of total expenses) in Russian Federation in 2010?
Your answer should be very brief. -25.26. What is the difference between the Expenses (% of total expenses) in Nigeria in 2009 and the Expenses (% of total expenses) in Russian Federation in 2010?
Your answer should be compact. -37.41. What is the difference between the Expenses (% of total expenses) in European Union in 2009 and the Expenses (% of total expenses) in Middle East & North Africa (developing only) in 2011?
Your answer should be very brief. 23.07. What is the difference between the Expenses (% of total expenses) of European Union in 2009 and the Expenses (% of total expenses) of Nigeria in 2011?
Give a very brief answer. 40.53. What is the difference between the Expenses (% of total expenses) in European Union in 2009 and the Expenses (% of total expenses) in Russian Federation in 2011?
Provide a succinct answer. 3.66. What is the difference between the Expenses (% of total expenses) in Middle East & North Africa (developing only) in 2009 and the Expenses (% of total expenses) in Nigeria in 2011?
Your answer should be very brief. 12.31. What is the difference between the Expenses (% of total expenses) in Middle East & North Africa (developing only) in 2009 and the Expenses (% of total expenses) in Russian Federation in 2011?
Offer a terse response. -24.56. What is the difference between the Expenses (% of total expenses) of Nigeria in 2009 and the Expenses (% of total expenses) of Russian Federation in 2011?
Your response must be concise. -36.71. What is the difference between the Expenses (% of total expenses) in European Union in 2010 and the Expenses (% of total expenses) in Middle East & North Africa (developing only) in 2011?
Your answer should be very brief. 23.81. What is the difference between the Expenses (% of total expenses) of European Union in 2010 and the Expenses (% of total expenses) of Nigeria in 2011?
Provide a succinct answer. 41.28. What is the difference between the Expenses (% of total expenses) of European Union in 2010 and the Expenses (% of total expenses) of Russian Federation in 2011?
Give a very brief answer. 4.4. What is the difference between the Expenses (% of total expenses) of Middle East & North Africa (developing only) in 2010 and the Expenses (% of total expenses) of Nigeria in 2011?
Offer a terse response. 14.41. What is the difference between the Expenses (% of total expenses) of Middle East & North Africa (developing only) in 2010 and the Expenses (% of total expenses) of Russian Federation in 2011?
Your answer should be very brief. -22.46. What is the difference between the Expenses (% of total expenses) of Nigeria in 2010 and the Expenses (% of total expenses) of Russian Federation in 2011?
Provide a succinct answer. -43.75. What is the average Expenses (% of total expenses) of European Union per year?
Provide a succinct answer. 61.76. What is the average Expenses (% of total expenses) in Middle East & North Africa (developing only) per year?
Ensure brevity in your answer.  33.92. What is the average Expenses (% of total expenses) of Nigeria per year?
Your answer should be compact. 23.02. What is the average Expenses (% of total expenses) in Russian Federation per year?
Your answer should be very brief. 55.87. In the year 2004, what is the difference between the Expenses (% of total expenses) in European Union and Expenses (% of total expenses) in Middle East & North Africa (developing only)?
Your answer should be compact. 31.14. In the year 2004, what is the difference between the Expenses (% of total expenses) of European Union and Expenses (% of total expenses) of Nigeria?
Your answer should be very brief. 35.52. In the year 2004, what is the difference between the Expenses (% of total expenses) of European Union and Expenses (% of total expenses) of Russian Federation?
Provide a succinct answer. 13.05. In the year 2004, what is the difference between the Expenses (% of total expenses) in Middle East & North Africa (developing only) and Expenses (% of total expenses) in Nigeria?
Give a very brief answer. 4.37. In the year 2004, what is the difference between the Expenses (% of total expenses) in Middle East & North Africa (developing only) and Expenses (% of total expenses) in Russian Federation?
Keep it short and to the point. -18.09. In the year 2004, what is the difference between the Expenses (% of total expenses) of Nigeria and Expenses (% of total expenses) of Russian Federation?
Give a very brief answer. -22.47. In the year 2005, what is the difference between the Expenses (% of total expenses) of European Union and Expenses (% of total expenses) of Middle East & North Africa (developing only)?
Give a very brief answer. 28.96. In the year 2005, what is the difference between the Expenses (% of total expenses) of European Union and Expenses (% of total expenses) of Nigeria?
Keep it short and to the point. 34.63. In the year 2005, what is the difference between the Expenses (% of total expenses) of European Union and Expenses (% of total expenses) of Russian Federation?
Ensure brevity in your answer.  7.44. In the year 2005, what is the difference between the Expenses (% of total expenses) in Middle East & North Africa (developing only) and Expenses (% of total expenses) in Nigeria?
Keep it short and to the point. 5.67. In the year 2005, what is the difference between the Expenses (% of total expenses) of Middle East & North Africa (developing only) and Expenses (% of total expenses) of Russian Federation?
Give a very brief answer. -21.52. In the year 2005, what is the difference between the Expenses (% of total expenses) of Nigeria and Expenses (% of total expenses) of Russian Federation?
Offer a very short reply. -27.19. In the year 2006, what is the difference between the Expenses (% of total expenses) of European Union and Expenses (% of total expenses) of Middle East & North Africa (developing only)?
Your answer should be compact. 28.67. In the year 2006, what is the difference between the Expenses (% of total expenses) in European Union and Expenses (% of total expenses) in Nigeria?
Give a very brief answer. 30.65. In the year 2006, what is the difference between the Expenses (% of total expenses) of European Union and Expenses (% of total expenses) of Russian Federation?
Provide a succinct answer. 5.93. In the year 2006, what is the difference between the Expenses (% of total expenses) of Middle East & North Africa (developing only) and Expenses (% of total expenses) of Nigeria?
Your answer should be very brief. 1.99. In the year 2006, what is the difference between the Expenses (% of total expenses) of Middle East & North Africa (developing only) and Expenses (% of total expenses) of Russian Federation?
Provide a succinct answer. -22.73. In the year 2006, what is the difference between the Expenses (% of total expenses) of Nigeria and Expenses (% of total expenses) of Russian Federation?
Make the answer very short. -24.72. In the year 2007, what is the difference between the Expenses (% of total expenses) of European Union and Expenses (% of total expenses) of Middle East & North Africa (developing only)?
Your response must be concise. 32.33. In the year 2007, what is the difference between the Expenses (% of total expenses) in European Union and Expenses (% of total expenses) in Nigeria?
Provide a short and direct response. 41.61. In the year 2007, what is the difference between the Expenses (% of total expenses) of European Union and Expenses (% of total expenses) of Russian Federation?
Give a very brief answer. 9.42. In the year 2007, what is the difference between the Expenses (% of total expenses) in Middle East & North Africa (developing only) and Expenses (% of total expenses) in Nigeria?
Provide a succinct answer. 9.28. In the year 2007, what is the difference between the Expenses (% of total expenses) in Middle East & North Africa (developing only) and Expenses (% of total expenses) in Russian Federation?
Give a very brief answer. -22.91. In the year 2007, what is the difference between the Expenses (% of total expenses) of Nigeria and Expenses (% of total expenses) of Russian Federation?
Offer a very short reply. -32.19. In the year 2008, what is the difference between the Expenses (% of total expenses) of European Union and Expenses (% of total expenses) of Middle East & North Africa (developing only)?
Keep it short and to the point. 24.54. In the year 2008, what is the difference between the Expenses (% of total expenses) in European Union and Expenses (% of total expenses) in Nigeria?
Provide a succinct answer. 39.5. In the year 2008, what is the difference between the Expenses (% of total expenses) of European Union and Expenses (% of total expenses) of Russian Federation?
Your response must be concise. 2.28. In the year 2008, what is the difference between the Expenses (% of total expenses) in Middle East & North Africa (developing only) and Expenses (% of total expenses) in Nigeria?
Keep it short and to the point. 14.95. In the year 2008, what is the difference between the Expenses (% of total expenses) in Middle East & North Africa (developing only) and Expenses (% of total expenses) in Russian Federation?
Offer a very short reply. -22.26. In the year 2008, what is the difference between the Expenses (% of total expenses) of Nigeria and Expenses (% of total expenses) of Russian Federation?
Your response must be concise. -37.21. In the year 2009, what is the difference between the Expenses (% of total expenses) in European Union and Expenses (% of total expenses) in Middle East & North Africa (developing only)?
Your answer should be very brief. 28.22. In the year 2009, what is the difference between the Expenses (% of total expenses) in European Union and Expenses (% of total expenses) in Nigeria?
Offer a very short reply. 40.37. In the year 2009, what is the difference between the Expenses (% of total expenses) in European Union and Expenses (% of total expenses) in Russian Federation?
Keep it short and to the point. 2.69. In the year 2009, what is the difference between the Expenses (% of total expenses) of Middle East & North Africa (developing only) and Expenses (% of total expenses) of Nigeria?
Ensure brevity in your answer.  12.15. In the year 2009, what is the difference between the Expenses (% of total expenses) in Middle East & North Africa (developing only) and Expenses (% of total expenses) in Russian Federation?
Provide a short and direct response. -25.54. In the year 2009, what is the difference between the Expenses (% of total expenses) of Nigeria and Expenses (% of total expenses) of Russian Federation?
Your response must be concise. -37.69. In the year 2010, what is the difference between the Expenses (% of total expenses) in European Union and Expenses (% of total expenses) in Middle East & North Africa (developing only)?
Make the answer very short. 26.86. In the year 2010, what is the difference between the Expenses (% of total expenses) of European Union and Expenses (% of total expenses) of Nigeria?
Your answer should be very brief. 48.15. In the year 2010, what is the difference between the Expenses (% of total expenses) of European Union and Expenses (% of total expenses) of Russian Federation?
Your answer should be very brief. 3.71. In the year 2010, what is the difference between the Expenses (% of total expenses) in Middle East & North Africa (developing only) and Expenses (% of total expenses) in Nigeria?
Keep it short and to the point. 21.29. In the year 2010, what is the difference between the Expenses (% of total expenses) of Middle East & North Africa (developing only) and Expenses (% of total expenses) of Russian Federation?
Your answer should be very brief. -23.15. In the year 2010, what is the difference between the Expenses (% of total expenses) in Nigeria and Expenses (% of total expenses) in Russian Federation?
Provide a succinct answer. -44.44. In the year 2011, what is the difference between the Expenses (% of total expenses) of European Union and Expenses (% of total expenses) of Middle East & North Africa (developing only)?
Ensure brevity in your answer.  22.03. In the year 2011, what is the difference between the Expenses (% of total expenses) in European Union and Expenses (% of total expenses) in Nigeria?
Offer a very short reply. 39.5. In the year 2011, what is the difference between the Expenses (% of total expenses) of European Union and Expenses (% of total expenses) of Russian Federation?
Your answer should be very brief. 2.62. In the year 2011, what is the difference between the Expenses (% of total expenses) in Middle East & North Africa (developing only) and Expenses (% of total expenses) in Nigeria?
Your answer should be very brief. 17.47. In the year 2011, what is the difference between the Expenses (% of total expenses) of Middle East & North Africa (developing only) and Expenses (% of total expenses) of Russian Federation?
Ensure brevity in your answer.  -19.4. In the year 2011, what is the difference between the Expenses (% of total expenses) of Nigeria and Expenses (% of total expenses) of Russian Federation?
Offer a very short reply. -36.87. What is the ratio of the Expenses (% of total expenses) in European Union in 2004 to that in 2005?
Keep it short and to the point. 0.98. What is the ratio of the Expenses (% of total expenses) in Middle East & North Africa (developing only) in 2004 to that in 2005?
Give a very brief answer. 0.89. What is the ratio of the Expenses (% of total expenses) of Nigeria in 2004 to that in 2005?
Your answer should be very brief. 0.92. What is the ratio of the Expenses (% of total expenses) of Russian Federation in 2004 to that in 2005?
Your answer should be very brief. 0.87. What is the ratio of the Expenses (% of total expenses) of Middle East & North Africa (developing only) in 2004 to that in 2006?
Give a very brief answer. 0.87. What is the ratio of the Expenses (% of total expenses) of Nigeria in 2004 to that in 2006?
Make the answer very short. 0.78. What is the ratio of the Expenses (% of total expenses) in Russian Federation in 2004 to that in 2006?
Make the answer very short. 0.84. What is the ratio of the Expenses (% of total expenses) of Middle East & North Africa (developing only) in 2004 to that in 2007?
Your answer should be compact. 0.94. What is the ratio of the Expenses (% of total expenses) in Nigeria in 2004 to that in 2007?
Your answer should be very brief. 1.14. What is the ratio of the Expenses (% of total expenses) of Russian Federation in 2004 to that in 2007?
Keep it short and to the point. 0.87. What is the ratio of the Expenses (% of total expenses) of European Union in 2004 to that in 2008?
Provide a short and direct response. 0.96. What is the ratio of the Expenses (% of total expenses) in Middle East & North Africa (developing only) in 2004 to that in 2008?
Provide a short and direct response. 0.76. What is the ratio of the Expenses (% of total expenses) in Nigeria in 2004 to that in 2008?
Ensure brevity in your answer.  1.08. What is the ratio of the Expenses (% of total expenses) in Russian Federation in 2004 to that in 2008?
Your answer should be very brief. 0.78. What is the ratio of the Expenses (% of total expenses) in European Union in 2004 to that in 2009?
Provide a succinct answer. 0.93. What is the ratio of the Expenses (% of total expenses) in Middle East & North Africa (developing only) in 2004 to that in 2009?
Offer a terse response. 0.79. What is the ratio of the Expenses (% of total expenses) in Nigeria in 2004 to that in 2009?
Provide a short and direct response. 1.02. What is the ratio of the Expenses (% of total expenses) of Russian Federation in 2004 to that in 2009?
Your answer should be compact. 0.76. What is the ratio of the Expenses (% of total expenses) of European Union in 2004 to that in 2010?
Provide a succinct answer. 0.92. What is the ratio of the Expenses (% of total expenses) of Middle East & North Africa (developing only) in 2004 to that in 2010?
Your response must be concise. 0.75. What is the ratio of the Expenses (% of total expenses) of Nigeria in 2004 to that in 2010?
Your answer should be compact. 1.47. What is the ratio of the Expenses (% of total expenses) of Russian Federation in 2004 to that in 2010?
Give a very brief answer. 0.76. What is the ratio of the Expenses (% of total expenses) in European Union in 2004 to that in 2011?
Make the answer very short. 0.95. What is the ratio of the Expenses (% of total expenses) of Middle East & North Africa (developing only) in 2004 to that in 2011?
Your response must be concise. 0.69. What is the ratio of the Expenses (% of total expenses) of Nigeria in 2004 to that in 2011?
Offer a terse response. 1.03. What is the ratio of the Expenses (% of total expenses) in Russian Federation in 2004 to that in 2011?
Your response must be concise. 0.77. What is the ratio of the Expenses (% of total expenses) in Middle East & North Africa (developing only) in 2005 to that in 2006?
Ensure brevity in your answer.  0.97. What is the ratio of the Expenses (% of total expenses) in Nigeria in 2005 to that in 2006?
Ensure brevity in your answer.  0.85. What is the ratio of the Expenses (% of total expenses) in Russian Federation in 2005 to that in 2006?
Provide a succinct answer. 0.96. What is the ratio of the Expenses (% of total expenses) in European Union in 2005 to that in 2007?
Provide a short and direct response. 0.97. What is the ratio of the Expenses (% of total expenses) in Middle East & North Africa (developing only) in 2005 to that in 2007?
Keep it short and to the point. 1.05. What is the ratio of the Expenses (% of total expenses) of Nigeria in 2005 to that in 2007?
Ensure brevity in your answer.  1.25. What is the ratio of the Expenses (% of total expenses) in European Union in 2005 to that in 2008?
Give a very brief answer. 0.98. What is the ratio of the Expenses (% of total expenses) in Middle East & North Africa (developing only) in 2005 to that in 2008?
Offer a terse response. 0.85. What is the ratio of the Expenses (% of total expenses) in Nigeria in 2005 to that in 2008?
Your answer should be very brief. 1.18. What is the ratio of the Expenses (% of total expenses) of Russian Federation in 2005 to that in 2008?
Your response must be concise. 0.9. What is the ratio of the Expenses (% of total expenses) in European Union in 2005 to that in 2009?
Offer a very short reply. 0.95. What is the ratio of the Expenses (% of total expenses) in Middle East & North Africa (developing only) in 2005 to that in 2009?
Your response must be concise. 0.89. What is the ratio of the Expenses (% of total expenses) in Nigeria in 2005 to that in 2009?
Provide a succinct answer. 1.11. What is the ratio of the Expenses (% of total expenses) in Russian Federation in 2005 to that in 2009?
Your answer should be very brief. 0.87. What is the ratio of the Expenses (% of total expenses) of European Union in 2005 to that in 2010?
Offer a very short reply. 0.94. What is the ratio of the Expenses (% of total expenses) in Middle East & North Africa (developing only) in 2005 to that in 2010?
Offer a very short reply. 0.84. What is the ratio of the Expenses (% of total expenses) in Nigeria in 2005 to that in 2010?
Make the answer very short. 1.6. What is the ratio of the Expenses (% of total expenses) of Russian Federation in 2005 to that in 2010?
Keep it short and to the point. 0.87. What is the ratio of the Expenses (% of total expenses) in European Union in 2005 to that in 2011?
Offer a very short reply. 0.97. What is the ratio of the Expenses (% of total expenses) in Middle East & North Africa (developing only) in 2005 to that in 2011?
Provide a succinct answer. 0.78. What is the ratio of the Expenses (% of total expenses) in Nigeria in 2005 to that in 2011?
Your answer should be very brief. 1.12. What is the ratio of the Expenses (% of total expenses) of Russian Federation in 2005 to that in 2011?
Provide a succinct answer. 0.88. What is the ratio of the Expenses (% of total expenses) in European Union in 2006 to that in 2007?
Offer a terse response. 0.98. What is the ratio of the Expenses (% of total expenses) of Middle East & North Africa (developing only) in 2006 to that in 2007?
Your response must be concise. 1.08. What is the ratio of the Expenses (% of total expenses) of Nigeria in 2006 to that in 2007?
Your answer should be very brief. 1.47. What is the ratio of the Expenses (% of total expenses) in Russian Federation in 2006 to that in 2007?
Offer a terse response. 1.04. What is the ratio of the Expenses (% of total expenses) of European Union in 2006 to that in 2008?
Offer a very short reply. 0.99. What is the ratio of the Expenses (% of total expenses) of Middle East & North Africa (developing only) in 2006 to that in 2008?
Your answer should be very brief. 0.88. What is the ratio of the Expenses (% of total expenses) of Nigeria in 2006 to that in 2008?
Give a very brief answer. 1.38. What is the ratio of the Expenses (% of total expenses) of Russian Federation in 2006 to that in 2008?
Keep it short and to the point. 0.93. What is the ratio of the Expenses (% of total expenses) in European Union in 2006 to that in 2009?
Offer a very short reply. 0.96. What is the ratio of the Expenses (% of total expenses) in Middle East & North Africa (developing only) in 2006 to that in 2009?
Provide a succinct answer. 0.92. What is the ratio of the Expenses (% of total expenses) in Nigeria in 2006 to that in 2009?
Provide a succinct answer. 1.31. What is the ratio of the Expenses (% of total expenses) in Russian Federation in 2006 to that in 2009?
Offer a very short reply. 0.9. What is the ratio of the Expenses (% of total expenses) of European Union in 2006 to that in 2010?
Provide a short and direct response. 0.95. What is the ratio of the Expenses (% of total expenses) in Middle East & North Africa (developing only) in 2006 to that in 2010?
Keep it short and to the point. 0.86. What is the ratio of the Expenses (% of total expenses) in Nigeria in 2006 to that in 2010?
Your answer should be compact. 1.88. What is the ratio of the Expenses (% of total expenses) of Russian Federation in 2006 to that in 2010?
Your response must be concise. 0.91. What is the ratio of the Expenses (% of total expenses) in European Union in 2006 to that in 2011?
Your response must be concise. 0.98. What is the ratio of the Expenses (% of total expenses) in Middle East & North Africa (developing only) in 2006 to that in 2011?
Ensure brevity in your answer.  0.8. What is the ratio of the Expenses (% of total expenses) of Nigeria in 2006 to that in 2011?
Offer a terse response. 1.32. What is the ratio of the Expenses (% of total expenses) of Russian Federation in 2006 to that in 2011?
Provide a succinct answer. 0.92. What is the ratio of the Expenses (% of total expenses) of European Union in 2007 to that in 2008?
Make the answer very short. 1.01. What is the ratio of the Expenses (% of total expenses) of Middle East & North Africa (developing only) in 2007 to that in 2008?
Your answer should be compact. 0.81. What is the ratio of the Expenses (% of total expenses) of Nigeria in 2007 to that in 2008?
Provide a short and direct response. 0.94. What is the ratio of the Expenses (% of total expenses) of Russian Federation in 2007 to that in 2008?
Offer a very short reply. 0.89. What is the ratio of the Expenses (% of total expenses) in Middle East & North Africa (developing only) in 2007 to that in 2009?
Make the answer very short. 0.85. What is the ratio of the Expenses (% of total expenses) in Nigeria in 2007 to that in 2009?
Keep it short and to the point. 0.89. What is the ratio of the Expenses (% of total expenses) of Russian Federation in 2007 to that in 2009?
Provide a succinct answer. 0.87. What is the ratio of the Expenses (% of total expenses) in European Union in 2007 to that in 2010?
Your response must be concise. 0.97. What is the ratio of the Expenses (% of total expenses) in Middle East & North Africa (developing only) in 2007 to that in 2010?
Make the answer very short. 0.8. What is the ratio of the Expenses (% of total expenses) of Nigeria in 2007 to that in 2010?
Your response must be concise. 1.28. What is the ratio of the Expenses (% of total expenses) of Russian Federation in 2007 to that in 2010?
Your answer should be very brief. 0.87. What is the ratio of the Expenses (% of total expenses) in Middle East & North Africa (developing only) in 2007 to that in 2011?
Your answer should be very brief. 0.74. What is the ratio of the Expenses (% of total expenses) in Nigeria in 2007 to that in 2011?
Provide a short and direct response. 0.9. What is the ratio of the Expenses (% of total expenses) of Russian Federation in 2007 to that in 2011?
Your answer should be very brief. 0.88. What is the ratio of the Expenses (% of total expenses) of European Union in 2008 to that in 2009?
Your answer should be very brief. 0.97. What is the ratio of the Expenses (% of total expenses) of Middle East & North Africa (developing only) in 2008 to that in 2009?
Make the answer very short. 1.04. What is the ratio of the Expenses (% of total expenses) of Nigeria in 2008 to that in 2009?
Offer a very short reply. 0.95. What is the ratio of the Expenses (% of total expenses) of Russian Federation in 2008 to that in 2009?
Provide a succinct answer. 0.97. What is the ratio of the Expenses (% of total expenses) of European Union in 2008 to that in 2010?
Your answer should be compact. 0.96. What is the ratio of the Expenses (% of total expenses) of Nigeria in 2008 to that in 2010?
Provide a succinct answer. 1.36. What is the ratio of the Expenses (% of total expenses) in Russian Federation in 2008 to that in 2010?
Give a very brief answer. 0.98. What is the ratio of the Expenses (% of total expenses) in European Union in 2008 to that in 2011?
Give a very brief answer. 0.98. What is the ratio of the Expenses (% of total expenses) in Middle East & North Africa (developing only) in 2008 to that in 2011?
Provide a succinct answer. 0.91. What is the ratio of the Expenses (% of total expenses) in Nigeria in 2008 to that in 2011?
Make the answer very short. 0.95. What is the ratio of the Expenses (% of total expenses) of Russian Federation in 2008 to that in 2011?
Ensure brevity in your answer.  0.99. What is the ratio of the Expenses (% of total expenses) in European Union in 2009 to that in 2010?
Offer a terse response. 0.99. What is the ratio of the Expenses (% of total expenses) in Middle East & North Africa (developing only) in 2009 to that in 2010?
Provide a succinct answer. 0.94. What is the ratio of the Expenses (% of total expenses) in Nigeria in 2009 to that in 2010?
Ensure brevity in your answer.  1.44. What is the ratio of the Expenses (% of total expenses) of European Union in 2009 to that in 2011?
Ensure brevity in your answer.  1.02. What is the ratio of the Expenses (% of total expenses) in Middle East & North Africa (developing only) in 2009 to that in 2011?
Offer a very short reply. 0.87. What is the ratio of the Expenses (% of total expenses) in Nigeria in 2009 to that in 2011?
Offer a very short reply. 1.01. What is the ratio of the Expenses (% of total expenses) in Russian Federation in 2009 to that in 2011?
Your answer should be compact. 1.02. What is the ratio of the Expenses (% of total expenses) in European Union in 2010 to that in 2011?
Your answer should be compact. 1.03. What is the ratio of the Expenses (% of total expenses) of Middle East & North Africa (developing only) in 2010 to that in 2011?
Ensure brevity in your answer.  0.92. What is the ratio of the Expenses (% of total expenses) of Nigeria in 2010 to that in 2011?
Make the answer very short. 0.7. What is the ratio of the Expenses (% of total expenses) in Russian Federation in 2010 to that in 2011?
Offer a terse response. 1.01. What is the difference between the highest and the second highest Expenses (% of total expenses) of European Union?
Your answer should be very brief. 0.74. What is the difference between the highest and the second highest Expenses (% of total expenses) in Middle East & North Africa (developing only)?
Keep it short and to the point. 3.05. What is the difference between the highest and the second highest Expenses (% of total expenses) of Nigeria?
Your response must be concise. 4.58. What is the difference between the highest and the second highest Expenses (% of total expenses) of Russian Federation?
Make the answer very short. 0.28. What is the difference between the highest and the lowest Expenses (% of total expenses) of European Union?
Make the answer very short. 5.12. What is the difference between the highest and the lowest Expenses (% of total expenses) in Middle East & North Africa (developing only)?
Provide a short and direct response. 12.46. What is the difference between the highest and the lowest Expenses (% of total expenses) of Nigeria?
Offer a very short reply. 14.2. What is the difference between the highest and the lowest Expenses (% of total expenses) in Russian Federation?
Offer a very short reply. 14.74. 